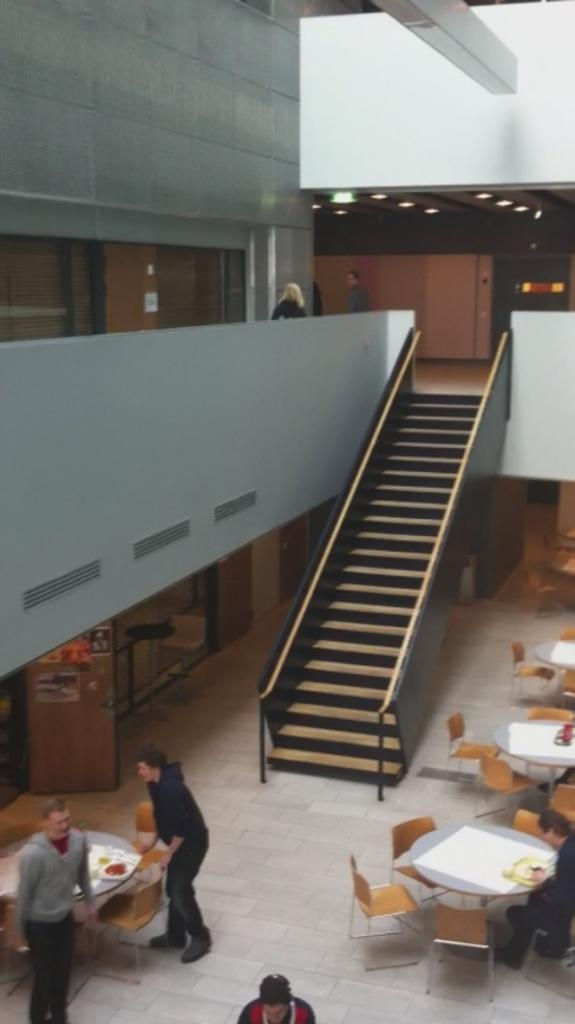How many people are present in the image? There are two people standing in the image. What is the position of the third person in the image? There is a person sitting on a chair on the right side of the image. What architectural feature can be seen in the background of the image? There are staircases in the background of the image. What type of structure is visible in the background of the image? There is an upper building visible in the background of the image. What can be seen illuminating the background of the image? There are lights present in the background of the image. What type of swing can be seen in the image? There is no swing present in the image. What day of the week is depicted in the image? The image does not depict a specific day of the week. 